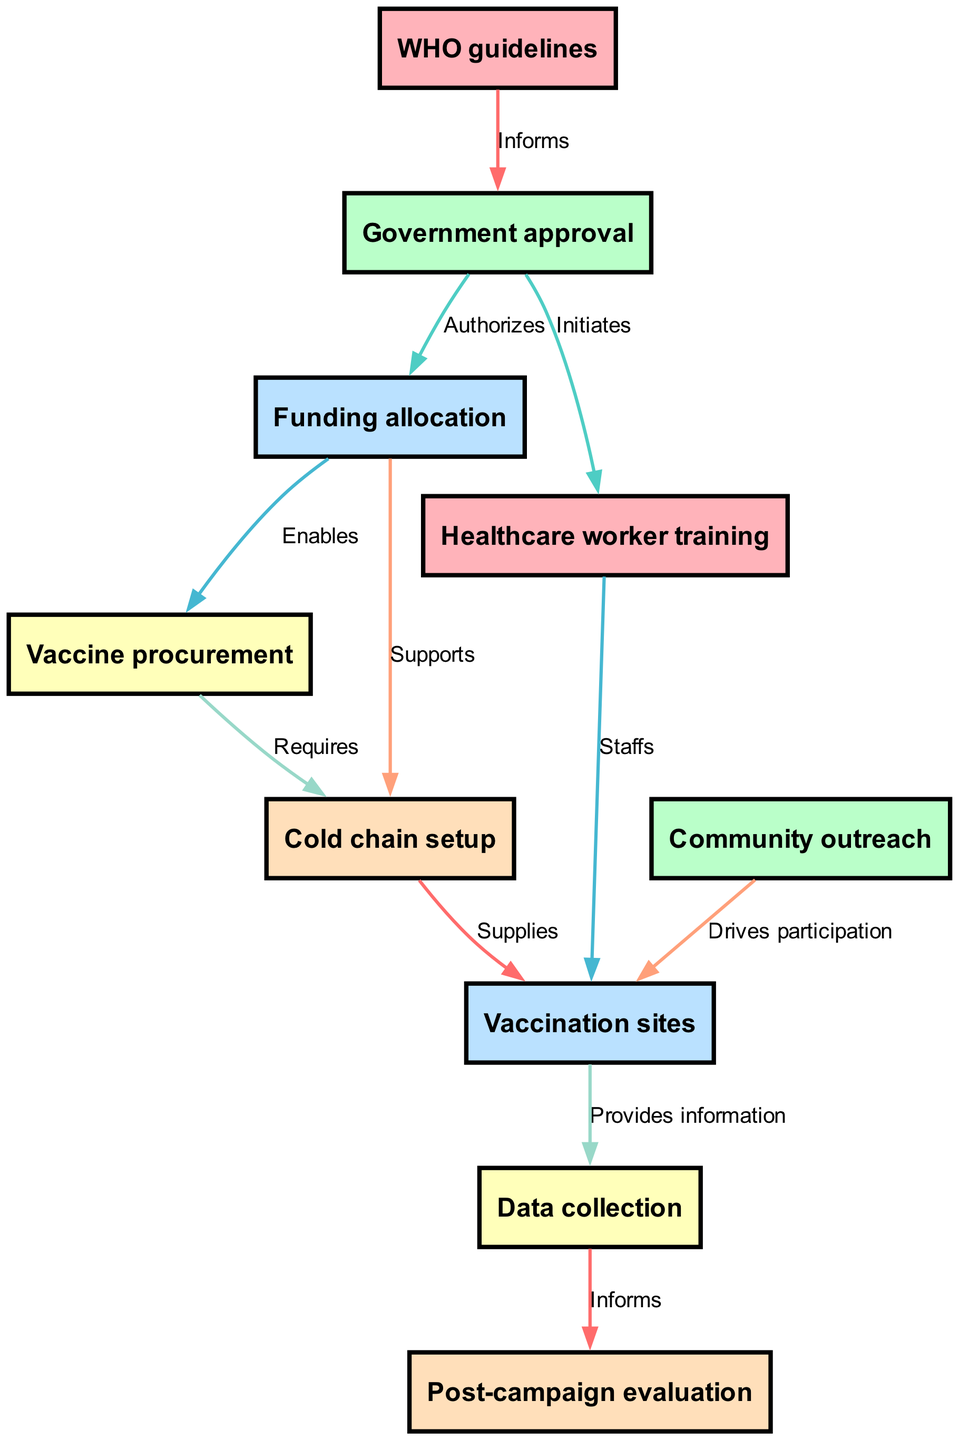What is the first node in the vaccination campaign process? The first node in the directed graph is "WHO guidelines." It is placed at the top of the diagram and serves as the initial reference for the campaign process.
Answer: WHO guidelines How many edges are in the diagram? To find the number of edges, count the connections between the nodes. There are 10 edges shown in the diagram, connecting various pairs of nodes in the vaccination process.
Answer: 10 What does "Funding allocation" authorize? "Funding allocation" authorizes "Vaccine procurement" as per the directed edge connecting these two nodes labeled "Authorizes." This relationship indicates that the allocation of funds is necessary for the vaccine procurement process to take place.
Answer: Vaccine procurement What node requires cold chain setup? The node "Vaccine procurement" has an edge leading to the node "Cold chain setup," labeled "Requires." This indicates that the process of procuring vaccines necessitates the establishment of a cold chain to ensure proper storage and handling.
Answer: Cold chain setup Which node directly supports the cold chain setup? The node "Funding allocation" directly supports the node "Cold chain setup" as illustrated by the edge labeled "Supports" connecting these two nodes. This shows that the availability of funds is crucial for setting up the cold chain.
Answer: Funding allocation How does community outreach affect vaccination sites? The directed edge from "Community outreach" to "Vaccination sites," labeled "Drives participation," indicates that effective outreach efforts directly lead to increased participation at the vaccination sites, emphasizing its importance in the vaccination campaign.
Answer: Drives participation What informs post-campaign evaluation? The node "Data collection" informs "Post-campaign evaluation." According to the directed edge labeled "Informs," the collected data will provide crucial feedback for evaluating the effectiveness of the vaccination campaign after it has concluded.
Answer: Data collection How many nodes are there in this diagram? By counting the distinct nodes in the diagram, we find there are 10 nodes that represent various steps and components in the vaccination campaign process, outlining the necessary elements.
Answer: 10 Which node initiates healthcare worker training? The node "Government approval" initiates "Healthcare worker training" as indicated by the edge connecting these nodes, labeled "Initiates." This shows that obtaining government approval is a prerequisite for training healthcare workers.
Answer: Government approval What supplies vaccination sites? The connection from "Cold chain setup" to "Vaccination sites," labeled "Supplies," indicates that the setup of the cold chain provides the necessary infrastructure and resources to enable the functioning of vaccination sites effectively.
Answer: Cold chain setup 